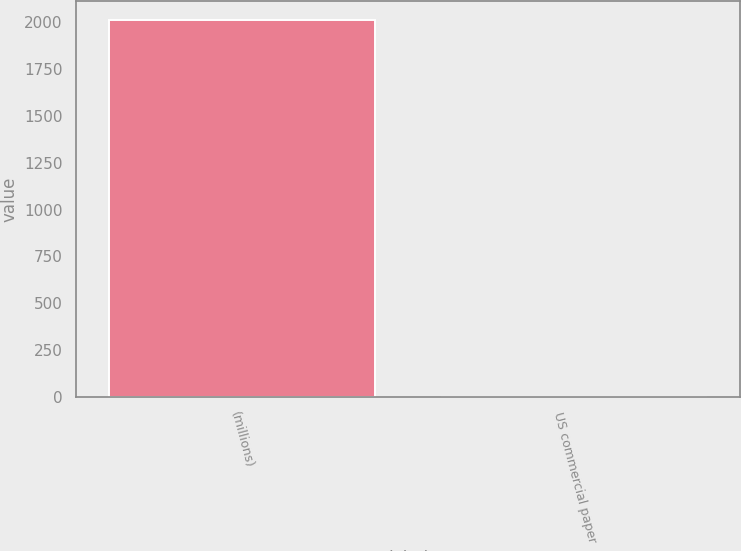Convert chart. <chart><loc_0><loc_0><loc_500><loc_500><bar_chart><fcel>(millions)<fcel>US commercial paper<nl><fcel>2011<fcel>0.24<nl></chart> 